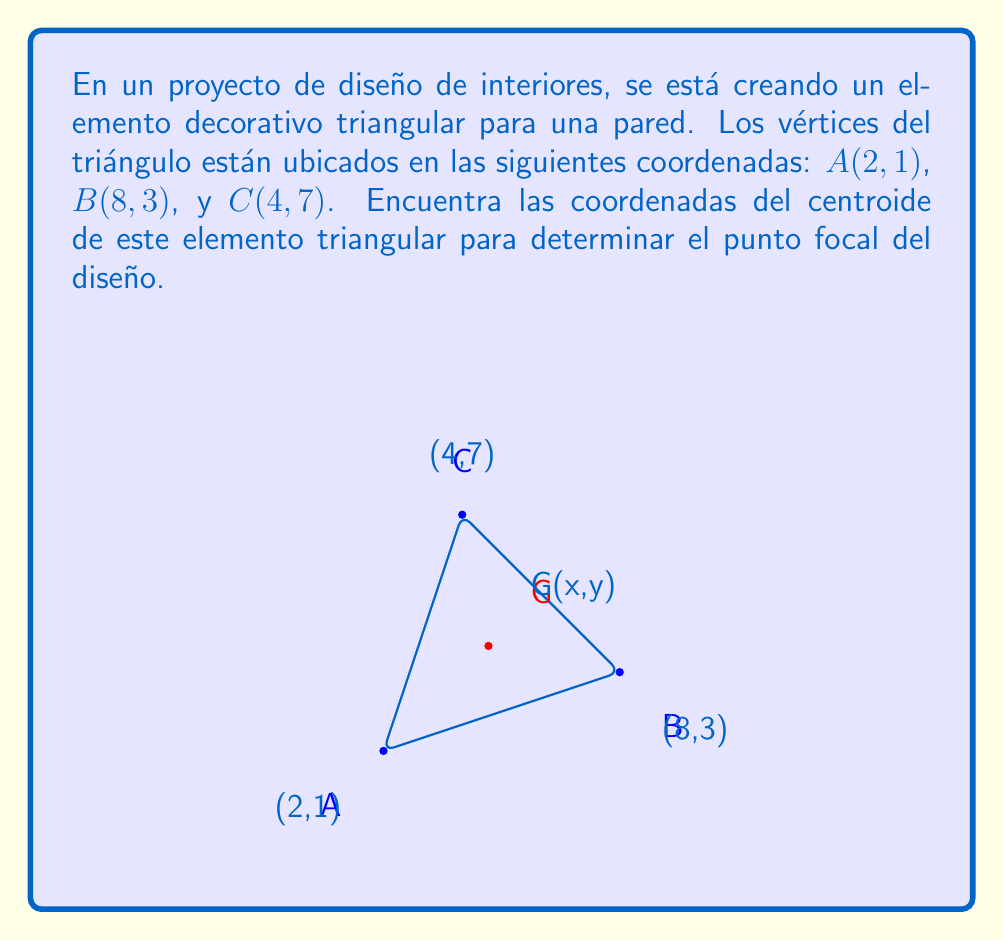Solve this math problem. Para encontrar el centroide de un triángulo, seguiremos estos pasos:

1) El centroide de un triángulo es el punto donde se intersectan las medianas. Sus coordenadas se pueden calcular promediando las coordenadas x e y de los tres vértices.

2) La fórmula para las coordenadas del centroide $(x_G, y_G)$ es:

   $$x_G = \frac{x_A + x_B + x_C}{3}$$
   $$y_G = \frac{y_A + y_B + y_C}{3}$$

   Donde $(x_A, y_A)$, $(x_B, y_B)$, y $(x_C, y_C)$ son las coordenadas de los vértices del triángulo.

3) Sustituyendo los valores dados:

   $$x_G = \frac{2 + 8 + 4}{3} = \frac{14}{3}$$
   $$y_G = \frac{1 + 3 + 7}{3} = \frac{11}{3}$$

4) Simplificando:

   $$x_G = \frac{14}{3} \approx 4.67$$
   $$y_G = \frac{11}{3} \approx 3.67$$

Por lo tanto, el centroide del elemento triangular se encuentra en el punto $(\frac{14}{3}, \frac{11}{3})$ o aproximadamente (4.67, 3.67) en el plano de diseño.
Answer: Las coordenadas del centroide son $(\frac{14}{3}, \frac{11}{3})$ o aproximadamente (4.67, 3.67). 